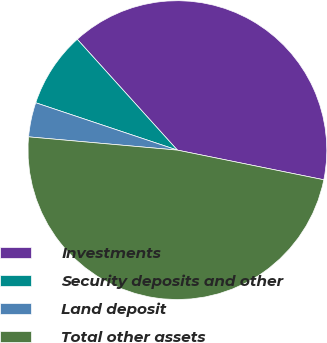<chart> <loc_0><loc_0><loc_500><loc_500><pie_chart><fcel>Investments<fcel>Security deposits and other<fcel>Land deposit<fcel>Total other assets<nl><fcel>39.87%<fcel>8.17%<fcel>3.72%<fcel>48.23%<nl></chart> 